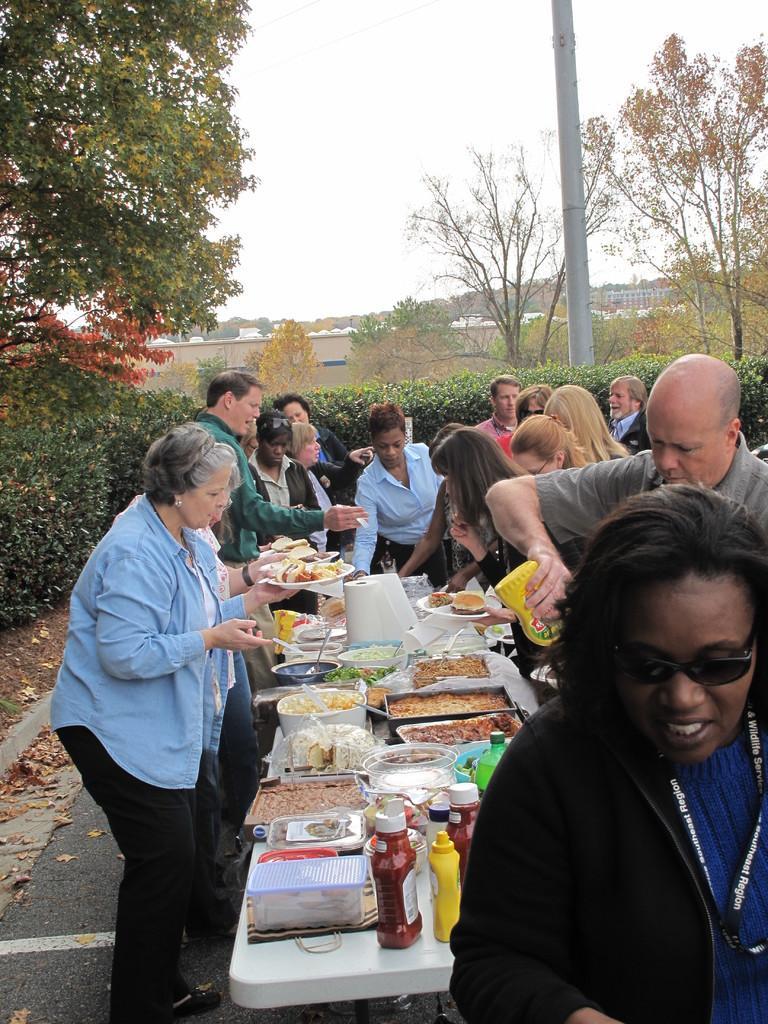Could you give a brief overview of what you see in this image? On the middle of the image there is a table. On the table there are many foods, bottles. Around the table there are many people. Some people are holding trees. On the top left there are trees. In the background there is pole,trees, building. 